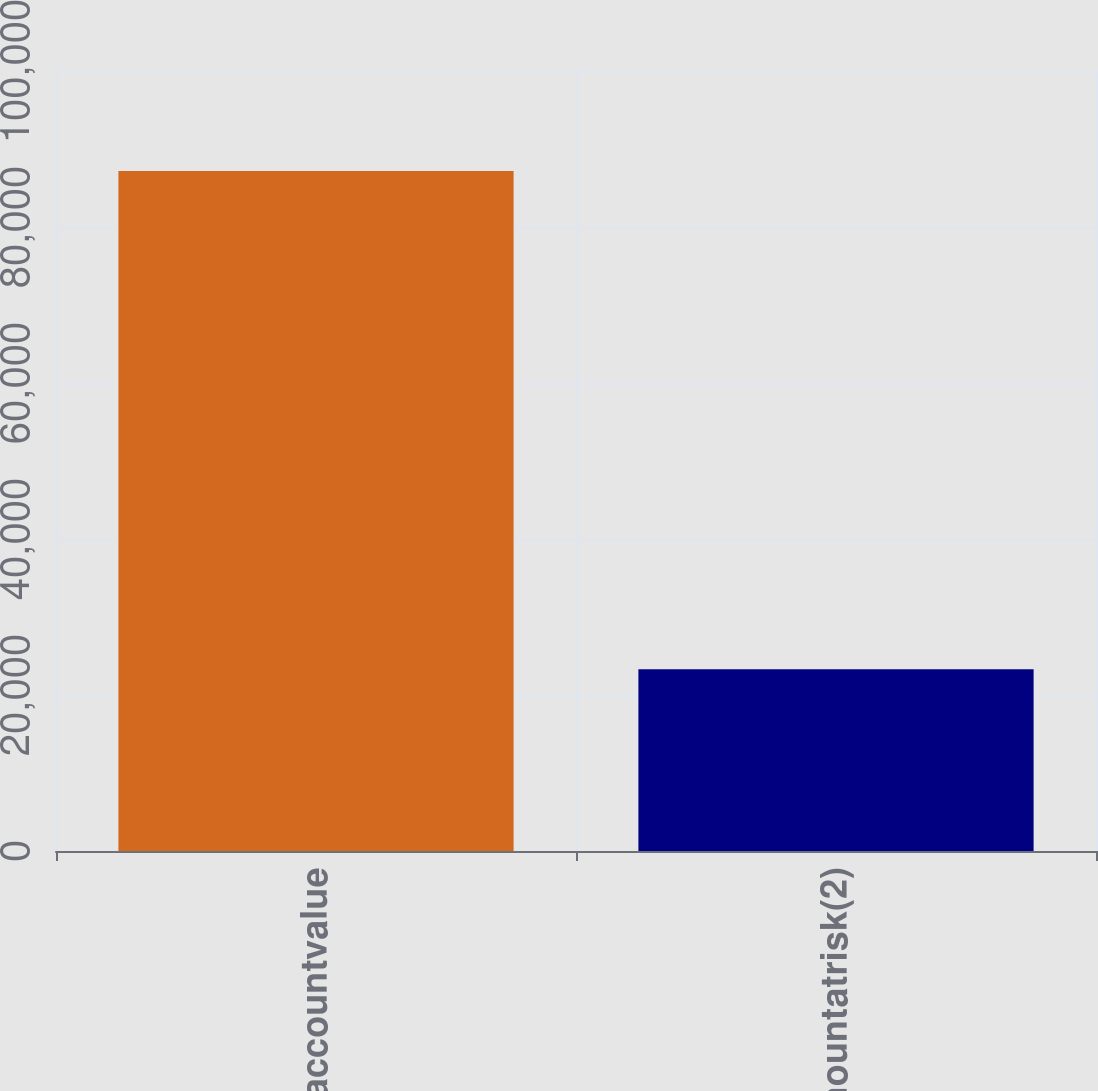<chart> <loc_0><loc_0><loc_500><loc_500><bar_chart><fcel>Separateaccountvalue<fcel>Netamountatrisk(2)<nl><fcel>87168<fcel>23313<nl></chart> 